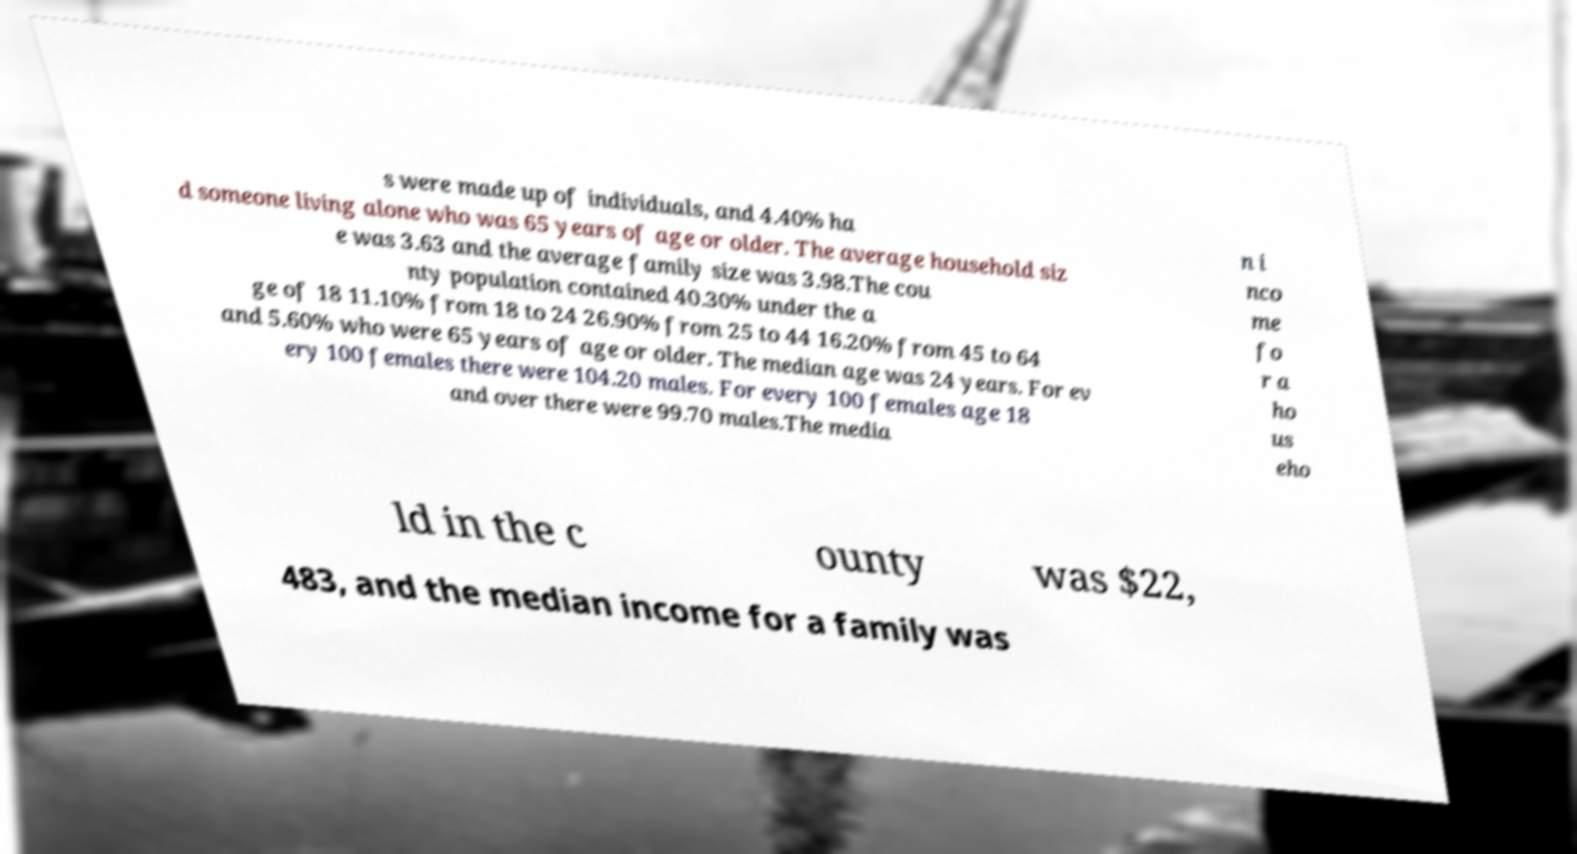Can you accurately transcribe the text from the provided image for me? s were made up of individuals, and 4.40% ha d someone living alone who was 65 years of age or older. The average household siz e was 3.63 and the average family size was 3.98.The cou nty population contained 40.30% under the a ge of 18 11.10% from 18 to 24 26.90% from 25 to 44 16.20% from 45 to 64 and 5.60% who were 65 years of age or older. The median age was 24 years. For ev ery 100 females there were 104.20 males. For every 100 females age 18 and over there were 99.70 males.The media n i nco me fo r a ho us eho ld in the c ounty was $22, 483, and the median income for a family was 